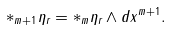<formula> <loc_0><loc_0><loc_500><loc_500>\ast _ { m + 1 } \eta _ { r } = \ast _ { m } \eta _ { r } \wedge d x ^ { m + 1 } .</formula> 